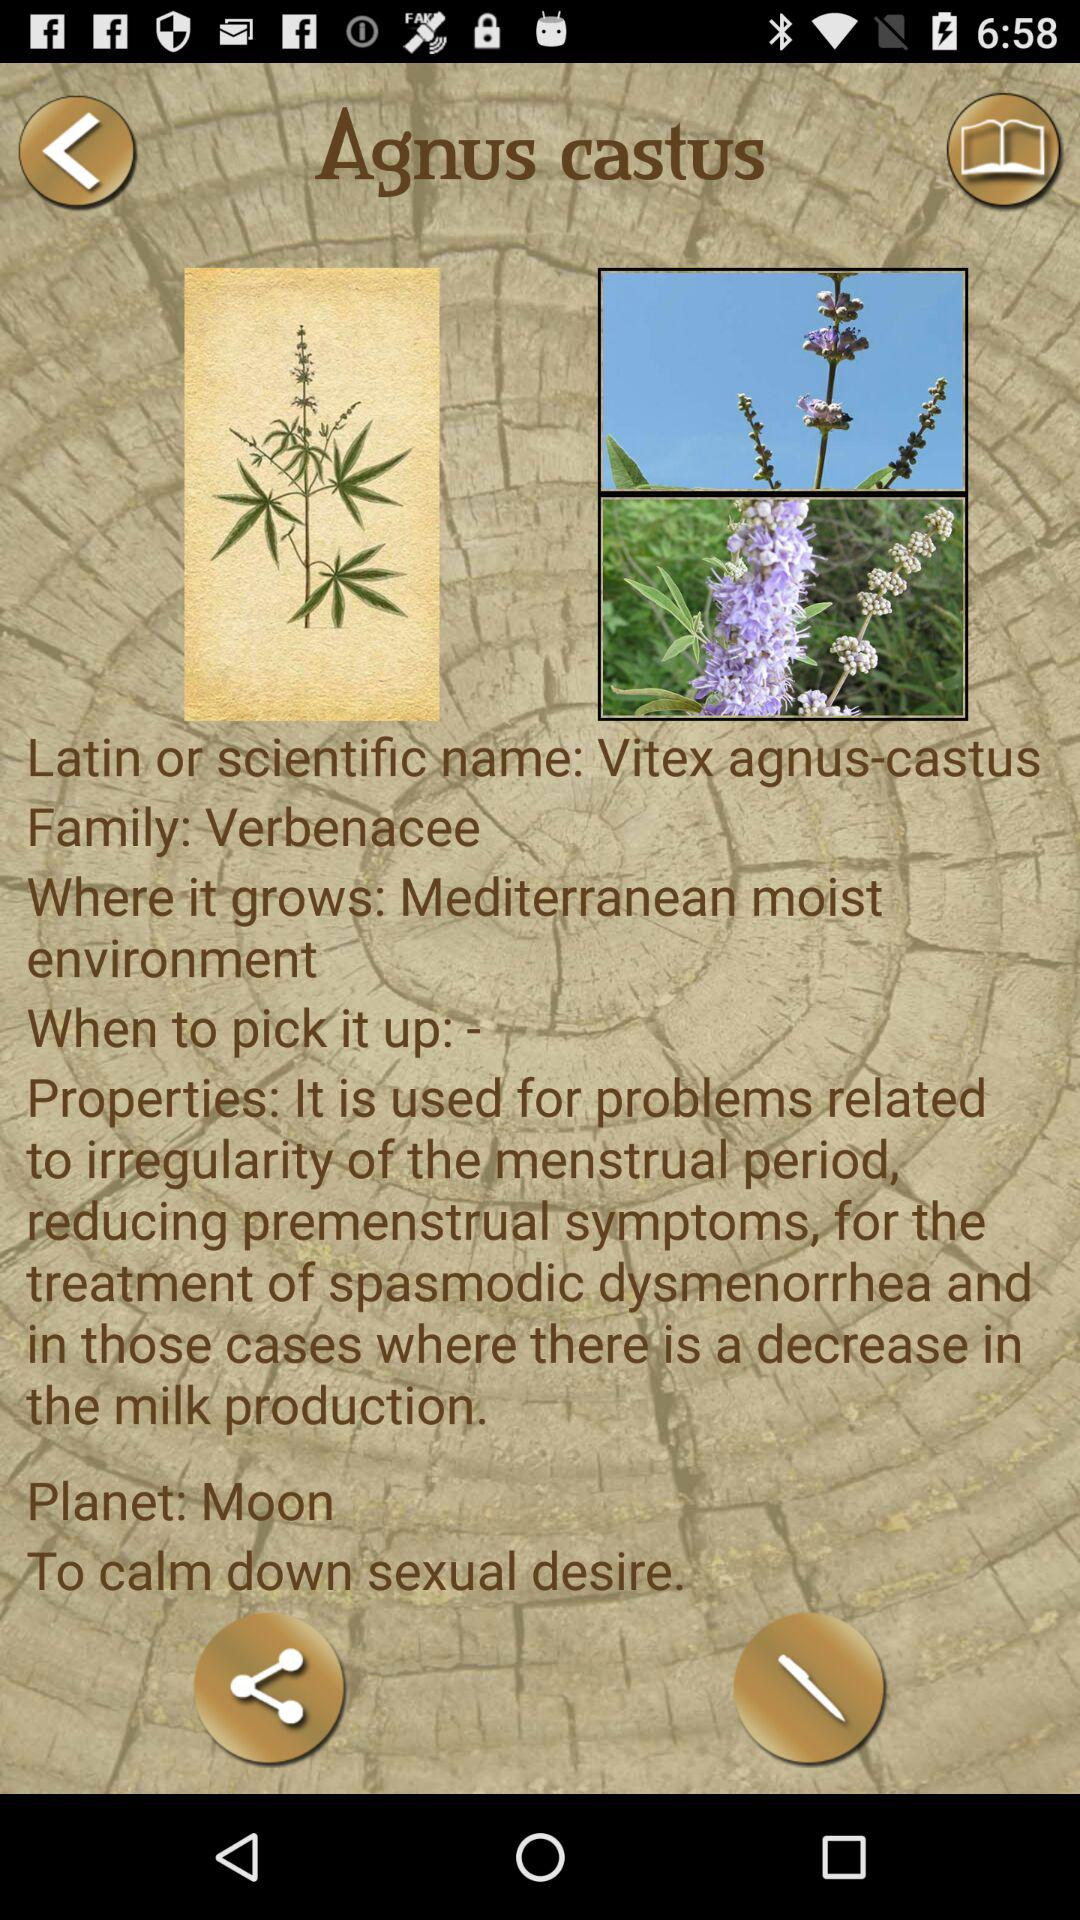What is the scientific name of Agnus castus? The scientific name of Agnus castus is Vitex agnus-castus. 